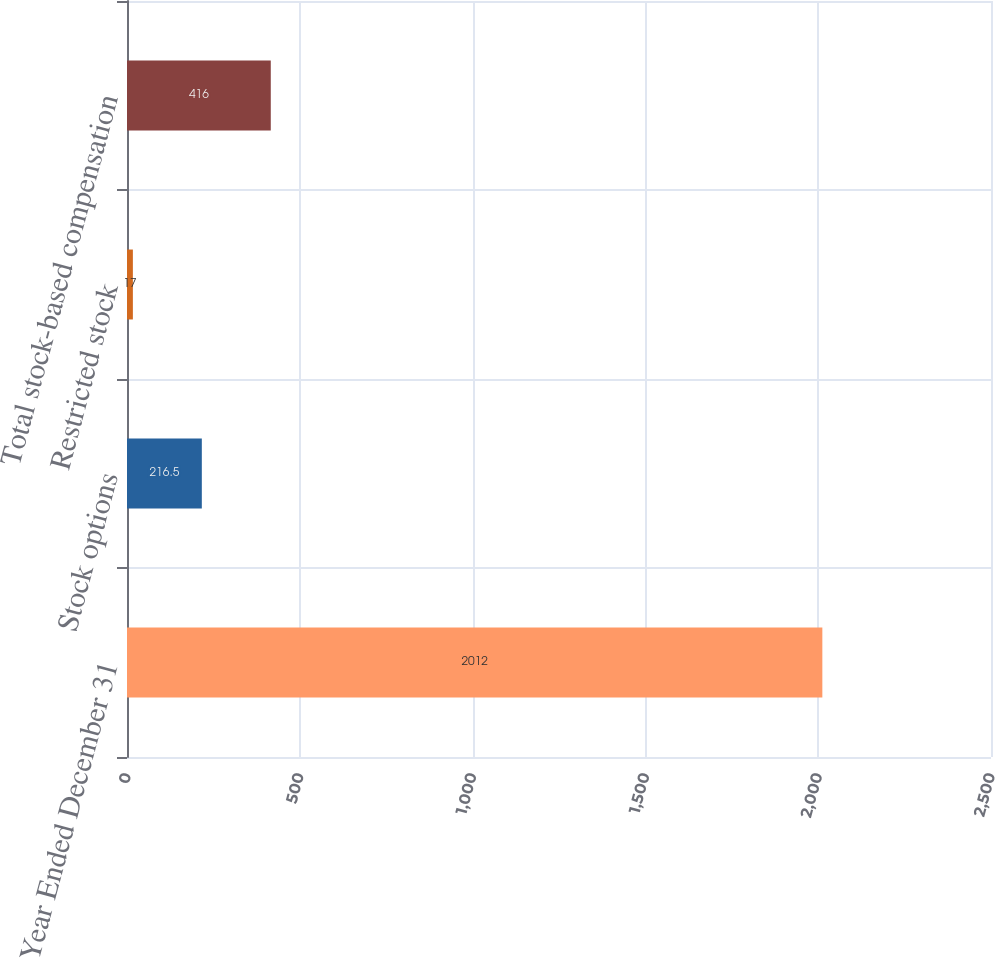Convert chart. <chart><loc_0><loc_0><loc_500><loc_500><bar_chart><fcel>Year Ended December 31<fcel>Stock options<fcel>Restricted stock<fcel>Total stock-based compensation<nl><fcel>2012<fcel>216.5<fcel>17<fcel>416<nl></chart> 